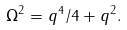<formula> <loc_0><loc_0><loc_500><loc_500>\Omega ^ { 2 } = q ^ { 4 } / 4 + q ^ { 2 } .</formula> 